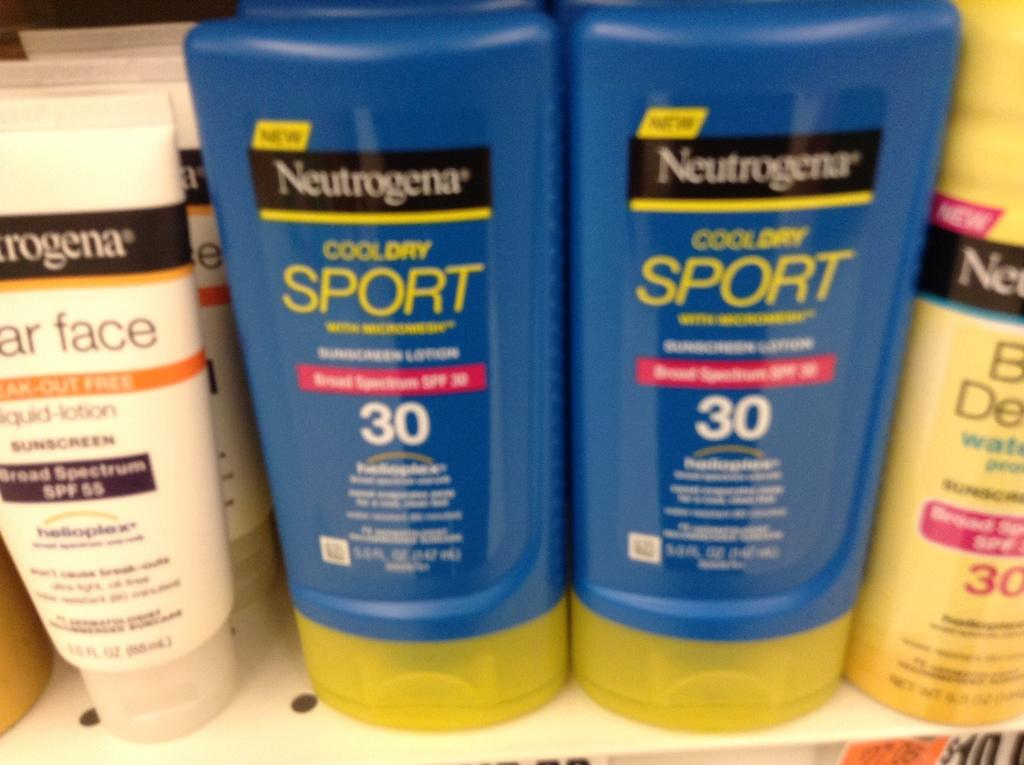Provide a one-sentence caption for the provided image. Blue tubes containing Neutrogena cool dry sport shampoo. 